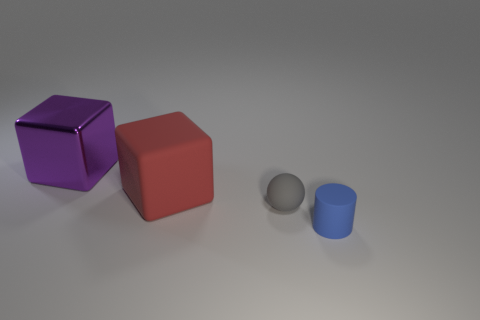Add 2 big brown things. How many objects exist? 6 Subtract all cylinders. How many objects are left? 3 Subtract all purple things. Subtract all brown rubber blocks. How many objects are left? 3 Add 2 red things. How many red things are left? 3 Add 4 purple metal things. How many purple metal things exist? 5 Subtract 0 cyan blocks. How many objects are left? 4 